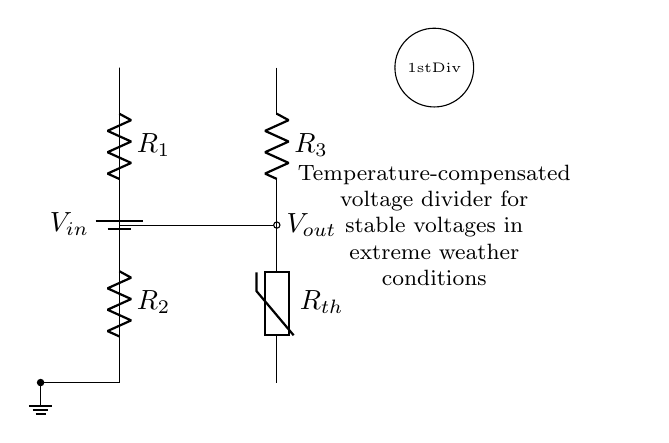What does the circuit primarily consist of? The circuit consists of a voltage divider with two resistors R1 and R2, a thermistor for temperature compensation, and a battery providing the input voltage.
Answer: Voltage divider, resistors, thermistor, battery What is the purpose of the thermistor in this circuit? The thermistor is used for temperature compensation to maintain stable output voltage despite variations in temperature, which is crucial in extreme weather conditions.
Answer: Temperature compensation How many resistors are present in the circuit? There are three resistors in the circuit: R1, R2, and R3.
Answer: Three What is the output voltage taken from? The output voltage is taken from the node between R1 and R2.
Answer: Node between R1 and R2 How does temperature affect the performance of this circuit? Temperature changes can alter the resistance of the thermistor, affecting the output voltage; the circuit is designed to mitigate these effects and provide stability.
Answer: It affects output voltage stability What specific type of circuit is this? This is a temperature-compensated voltage divider circuit.
Answer: Temperature-compensated voltage divider 